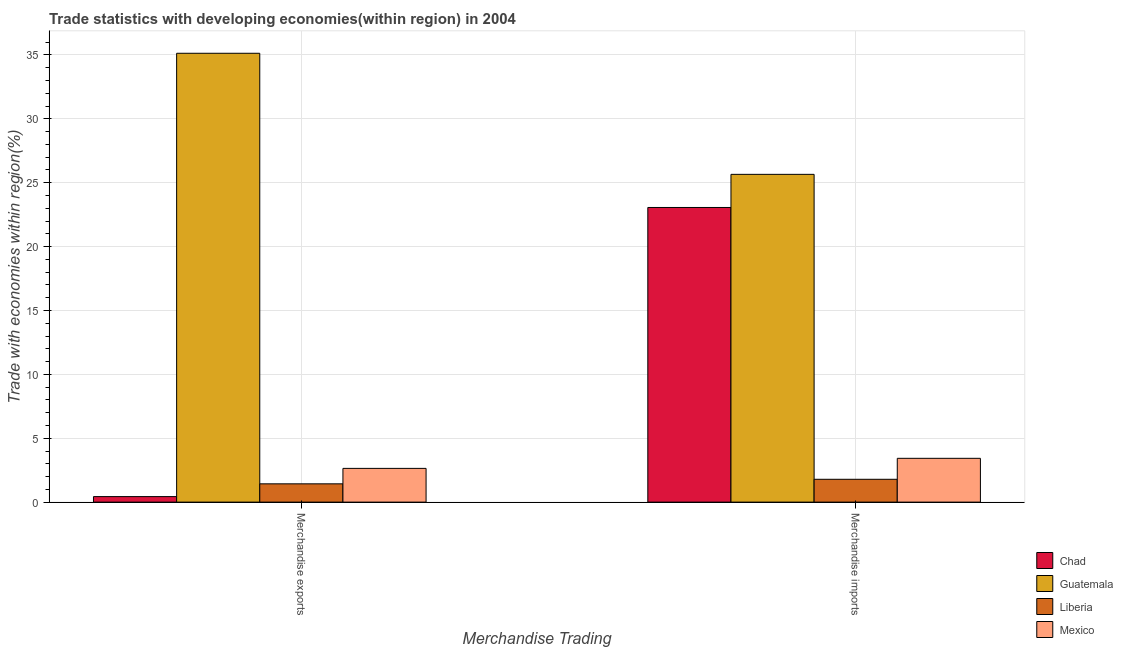How many different coloured bars are there?
Make the answer very short. 4. How many groups of bars are there?
Make the answer very short. 2. Are the number of bars on each tick of the X-axis equal?
Your response must be concise. Yes. How many bars are there on the 2nd tick from the left?
Your answer should be compact. 4. How many bars are there on the 1st tick from the right?
Offer a terse response. 4. What is the merchandise imports in Guatemala?
Your answer should be compact. 25.66. Across all countries, what is the maximum merchandise exports?
Provide a succinct answer. 35.14. Across all countries, what is the minimum merchandise exports?
Provide a succinct answer. 0.43. In which country was the merchandise imports maximum?
Provide a succinct answer. Guatemala. In which country was the merchandise exports minimum?
Offer a very short reply. Chad. What is the total merchandise exports in the graph?
Give a very brief answer. 39.64. What is the difference between the merchandise imports in Guatemala and that in Chad?
Ensure brevity in your answer.  2.59. What is the difference between the merchandise imports in Liberia and the merchandise exports in Chad?
Your answer should be compact. 1.36. What is the average merchandise exports per country?
Provide a short and direct response. 9.91. What is the difference between the merchandise exports and merchandise imports in Liberia?
Provide a succinct answer. -0.36. In how many countries, is the merchandise imports greater than 9 %?
Provide a short and direct response. 2. What is the ratio of the merchandise imports in Guatemala to that in Mexico?
Keep it short and to the point. 7.48. What does the 4th bar from the left in Merchandise exports represents?
Make the answer very short. Mexico. What does the 2nd bar from the right in Merchandise exports represents?
Ensure brevity in your answer.  Liberia. How many bars are there?
Your answer should be compact. 8. Are all the bars in the graph horizontal?
Keep it short and to the point. No. How many countries are there in the graph?
Your response must be concise. 4. What is the difference between two consecutive major ticks on the Y-axis?
Ensure brevity in your answer.  5. Does the graph contain any zero values?
Provide a succinct answer. No. Where does the legend appear in the graph?
Your answer should be very brief. Bottom right. How many legend labels are there?
Provide a succinct answer. 4. How are the legend labels stacked?
Provide a succinct answer. Vertical. What is the title of the graph?
Your answer should be compact. Trade statistics with developing economies(within region) in 2004. Does "Belgium" appear as one of the legend labels in the graph?
Your response must be concise. No. What is the label or title of the X-axis?
Provide a succinct answer. Merchandise Trading. What is the label or title of the Y-axis?
Your answer should be very brief. Trade with economies within region(%). What is the Trade with economies within region(%) in Chad in Merchandise exports?
Ensure brevity in your answer.  0.43. What is the Trade with economies within region(%) in Guatemala in Merchandise exports?
Offer a terse response. 35.14. What is the Trade with economies within region(%) in Liberia in Merchandise exports?
Offer a terse response. 1.43. What is the Trade with economies within region(%) of Mexico in Merchandise exports?
Offer a terse response. 2.64. What is the Trade with economies within region(%) in Chad in Merchandise imports?
Make the answer very short. 23.06. What is the Trade with economies within region(%) in Guatemala in Merchandise imports?
Offer a very short reply. 25.66. What is the Trade with economies within region(%) of Liberia in Merchandise imports?
Your response must be concise. 1.79. What is the Trade with economies within region(%) in Mexico in Merchandise imports?
Keep it short and to the point. 3.43. Across all Merchandise Trading, what is the maximum Trade with economies within region(%) in Chad?
Provide a short and direct response. 23.06. Across all Merchandise Trading, what is the maximum Trade with economies within region(%) of Guatemala?
Make the answer very short. 35.14. Across all Merchandise Trading, what is the maximum Trade with economies within region(%) in Liberia?
Provide a succinct answer. 1.79. Across all Merchandise Trading, what is the maximum Trade with economies within region(%) of Mexico?
Your answer should be very brief. 3.43. Across all Merchandise Trading, what is the minimum Trade with economies within region(%) in Chad?
Offer a very short reply. 0.43. Across all Merchandise Trading, what is the minimum Trade with economies within region(%) in Guatemala?
Your answer should be very brief. 25.66. Across all Merchandise Trading, what is the minimum Trade with economies within region(%) in Liberia?
Offer a very short reply. 1.43. Across all Merchandise Trading, what is the minimum Trade with economies within region(%) in Mexico?
Offer a very short reply. 2.64. What is the total Trade with economies within region(%) of Chad in the graph?
Your response must be concise. 23.5. What is the total Trade with economies within region(%) in Guatemala in the graph?
Keep it short and to the point. 60.79. What is the total Trade with economies within region(%) in Liberia in the graph?
Make the answer very short. 3.22. What is the total Trade with economies within region(%) in Mexico in the graph?
Give a very brief answer. 6.07. What is the difference between the Trade with economies within region(%) of Chad in Merchandise exports and that in Merchandise imports?
Offer a very short reply. -22.63. What is the difference between the Trade with economies within region(%) in Guatemala in Merchandise exports and that in Merchandise imports?
Offer a very short reply. 9.48. What is the difference between the Trade with economies within region(%) of Liberia in Merchandise exports and that in Merchandise imports?
Provide a short and direct response. -0.36. What is the difference between the Trade with economies within region(%) of Mexico in Merchandise exports and that in Merchandise imports?
Your answer should be compact. -0.79. What is the difference between the Trade with economies within region(%) of Chad in Merchandise exports and the Trade with economies within region(%) of Guatemala in Merchandise imports?
Make the answer very short. -25.22. What is the difference between the Trade with economies within region(%) in Chad in Merchandise exports and the Trade with economies within region(%) in Liberia in Merchandise imports?
Your response must be concise. -1.36. What is the difference between the Trade with economies within region(%) of Chad in Merchandise exports and the Trade with economies within region(%) of Mexico in Merchandise imports?
Your answer should be very brief. -3. What is the difference between the Trade with economies within region(%) in Guatemala in Merchandise exports and the Trade with economies within region(%) in Liberia in Merchandise imports?
Provide a short and direct response. 33.35. What is the difference between the Trade with economies within region(%) of Guatemala in Merchandise exports and the Trade with economies within region(%) of Mexico in Merchandise imports?
Offer a very short reply. 31.71. What is the difference between the Trade with economies within region(%) in Liberia in Merchandise exports and the Trade with economies within region(%) in Mexico in Merchandise imports?
Keep it short and to the point. -2. What is the average Trade with economies within region(%) in Chad per Merchandise Trading?
Provide a short and direct response. 11.75. What is the average Trade with economies within region(%) in Guatemala per Merchandise Trading?
Give a very brief answer. 30.4. What is the average Trade with economies within region(%) of Liberia per Merchandise Trading?
Your answer should be very brief. 1.61. What is the average Trade with economies within region(%) of Mexico per Merchandise Trading?
Provide a succinct answer. 3.04. What is the difference between the Trade with economies within region(%) in Chad and Trade with economies within region(%) in Guatemala in Merchandise exports?
Give a very brief answer. -34.7. What is the difference between the Trade with economies within region(%) of Chad and Trade with economies within region(%) of Liberia in Merchandise exports?
Offer a very short reply. -1. What is the difference between the Trade with economies within region(%) in Chad and Trade with economies within region(%) in Mexico in Merchandise exports?
Offer a terse response. -2.21. What is the difference between the Trade with economies within region(%) in Guatemala and Trade with economies within region(%) in Liberia in Merchandise exports?
Your response must be concise. 33.7. What is the difference between the Trade with economies within region(%) in Guatemala and Trade with economies within region(%) in Mexico in Merchandise exports?
Offer a very short reply. 32.49. What is the difference between the Trade with economies within region(%) of Liberia and Trade with economies within region(%) of Mexico in Merchandise exports?
Provide a short and direct response. -1.21. What is the difference between the Trade with economies within region(%) in Chad and Trade with economies within region(%) in Guatemala in Merchandise imports?
Offer a very short reply. -2.59. What is the difference between the Trade with economies within region(%) in Chad and Trade with economies within region(%) in Liberia in Merchandise imports?
Provide a succinct answer. 21.28. What is the difference between the Trade with economies within region(%) of Chad and Trade with economies within region(%) of Mexico in Merchandise imports?
Your answer should be compact. 19.64. What is the difference between the Trade with economies within region(%) of Guatemala and Trade with economies within region(%) of Liberia in Merchandise imports?
Make the answer very short. 23.87. What is the difference between the Trade with economies within region(%) of Guatemala and Trade with economies within region(%) of Mexico in Merchandise imports?
Make the answer very short. 22.23. What is the difference between the Trade with economies within region(%) in Liberia and Trade with economies within region(%) in Mexico in Merchandise imports?
Your response must be concise. -1.64. What is the ratio of the Trade with economies within region(%) in Chad in Merchandise exports to that in Merchandise imports?
Keep it short and to the point. 0.02. What is the ratio of the Trade with economies within region(%) of Guatemala in Merchandise exports to that in Merchandise imports?
Your answer should be very brief. 1.37. What is the ratio of the Trade with economies within region(%) of Liberia in Merchandise exports to that in Merchandise imports?
Your response must be concise. 0.8. What is the ratio of the Trade with economies within region(%) in Mexico in Merchandise exports to that in Merchandise imports?
Offer a very short reply. 0.77. What is the difference between the highest and the second highest Trade with economies within region(%) in Chad?
Ensure brevity in your answer.  22.63. What is the difference between the highest and the second highest Trade with economies within region(%) of Guatemala?
Provide a short and direct response. 9.48. What is the difference between the highest and the second highest Trade with economies within region(%) of Liberia?
Provide a succinct answer. 0.36. What is the difference between the highest and the second highest Trade with economies within region(%) in Mexico?
Offer a very short reply. 0.79. What is the difference between the highest and the lowest Trade with economies within region(%) in Chad?
Make the answer very short. 22.63. What is the difference between the highest and the lowest Trade with economies within region(%) of Guatemala?
Provide a short and direct response. 9.48. What is the difference between the highest and the lowest Trade with economies within region(%) of Liberia?
Provide a short and direct response. 0.36. What is the difference between the highest and the lowest Trade with economies within region(%) in Mexico?
Your answer should be compact. 0.79. 